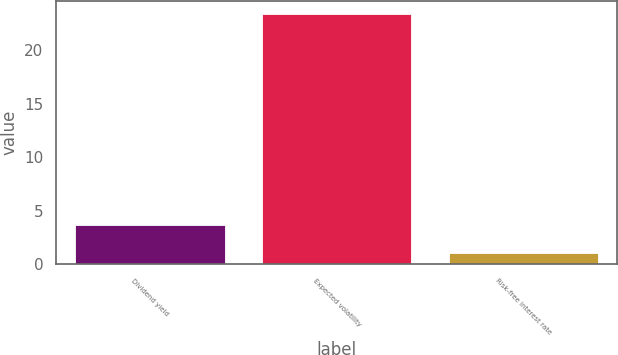<chart> <loc_0><loc_0><loc_500><loc_500><bar_chart><fcel>Dividend yield<fcel>Expected volatility<fcel>Risk-free interest rate<nl><fcel>3.7<fcel>23.4<fcel>1<nl></chart> 